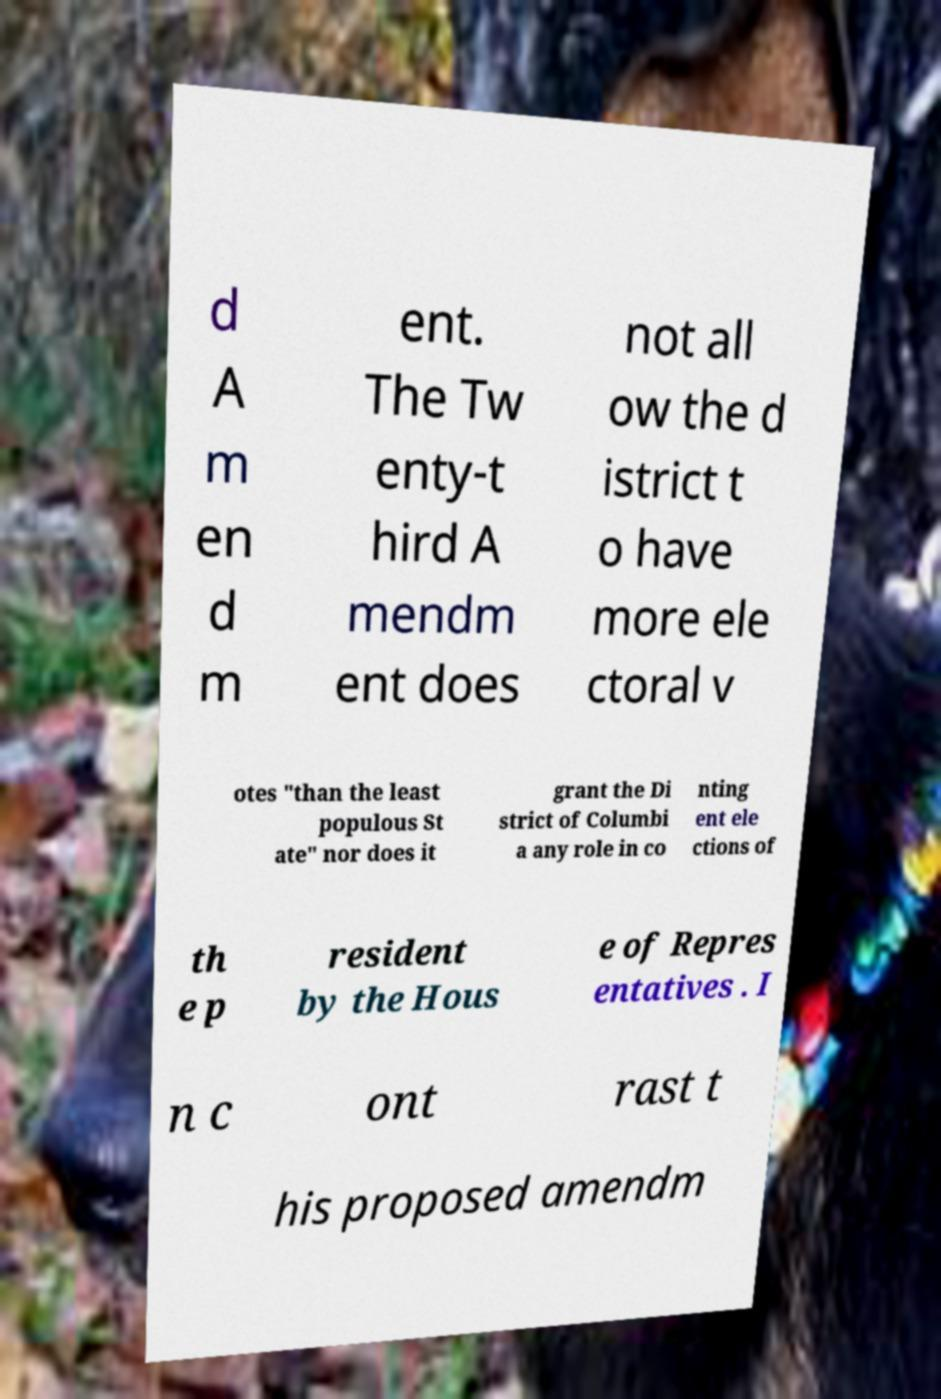Could you assist in decoding the text presented in this image and type it out clearly? d A m en d m ent. The Tw enty-t hird A mendm ent does not all ow the d istrict t o have more ele ctoral v otes "than the least populous St ate" nor does it grant the Di strict of Columbi a any role in co nting ent ele ctions of th e p resident by the Hous e of Repres entatives . I n c ont rast t his proposed amendm 